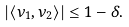<formula> <loc_0><loc_0><loc_500><loc_500>| \langle \nu _ { 1 } , \nu _ { 2 } \rangle | \leq 1 - \delta .</formula> 